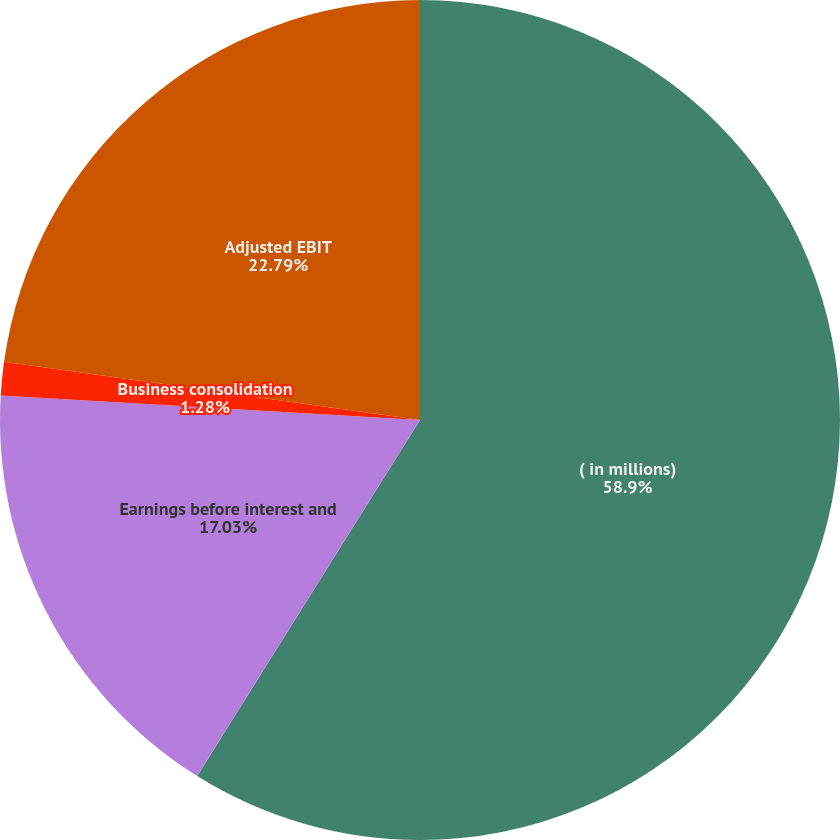Convert chart to OTSL. <chart><loc_0><loc_0><loc_500><loc_500><pie_chart><fcel>( in millions)<fcel>Earnings before interest and<fcel>Business consolidation<fcel>Adjusted EBIT<nl><fcel>58.9%<fcel>17.03%<fcel>1.28%<fcel>22.79%<nl></chart> 